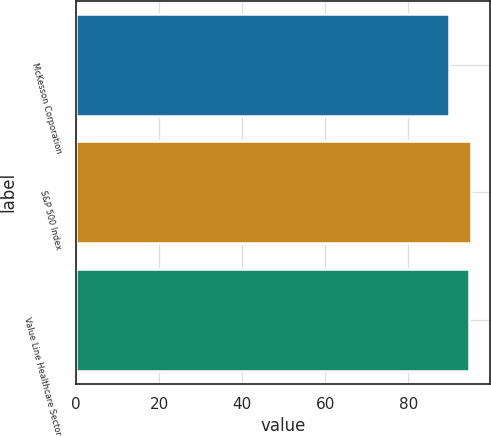<chart> <loc_0><loc_0><loc_500><loc_500><bar_chart><fcel>McKesson Corporation<fcel>S&P 500 Index<fcel>Value Line Healthcare Sector<nl><fcel>89.81<fcel>95.03<fcel>94.52<nl></chart> 